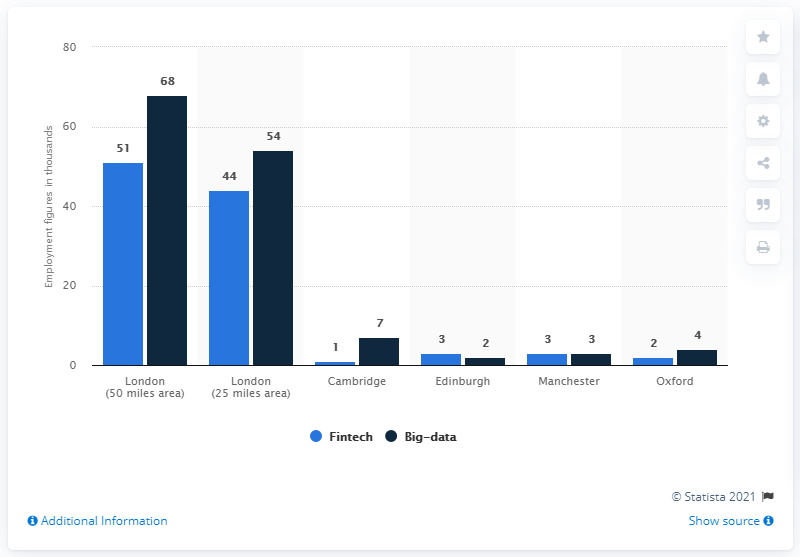Give some essential details in this illustration. Six areas have been considered. There are four areas where the difference between fintech and big data is less than 10. 